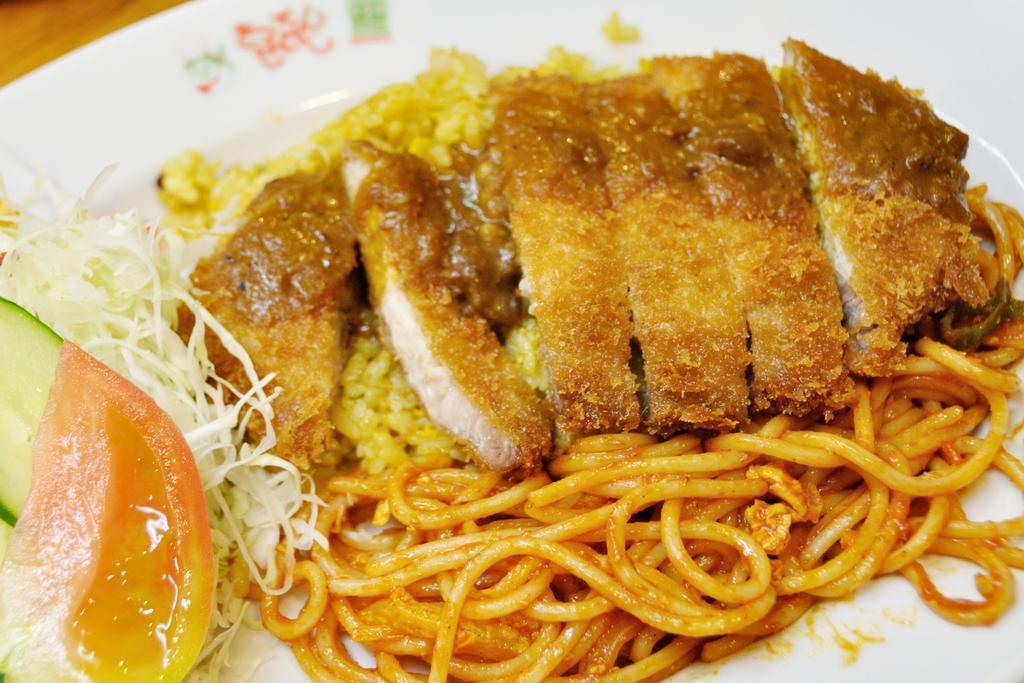In one or two sentences, can you explain what this image depicts? In this picture there is a plate in the center of the image which contains chowmein and salad in it. 